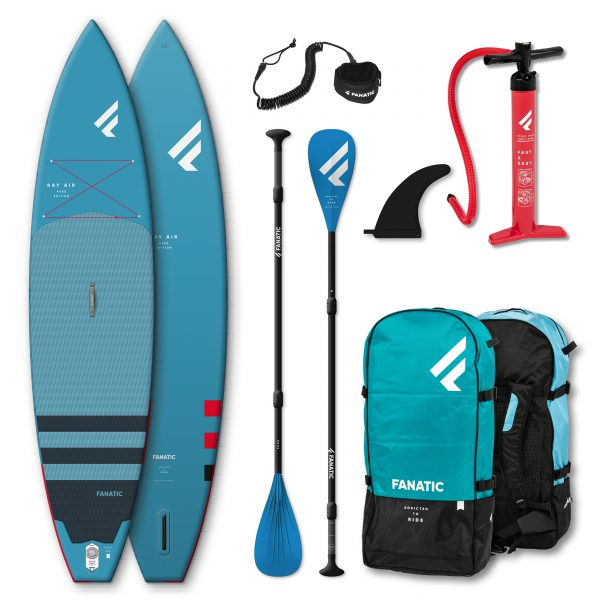If this paddleboarding set was to be featured in a futuristic movie, how do you imagine the setup would change? In a futuristic movie, this paddleboarding set could undergo some innovative transformations. The paddleboards might be made from hyper-light materials and equipped with self-inflating and deflating features for easy portability. The paddles could be augmented with smart technology, providing real-time data on speed, distance, and technique to enhance the paddling experience. The coiled leash might use magnetic or biometric technology to secure the paddler safely to the board. The carry bags could be smart backpacks with solar panels to power electronic devices and built-in GPS trackers for navigation. Additionally, the set might include a compact, foldable drone designed to follow and capture breathtaking footage of the paddleboarding adventure. 